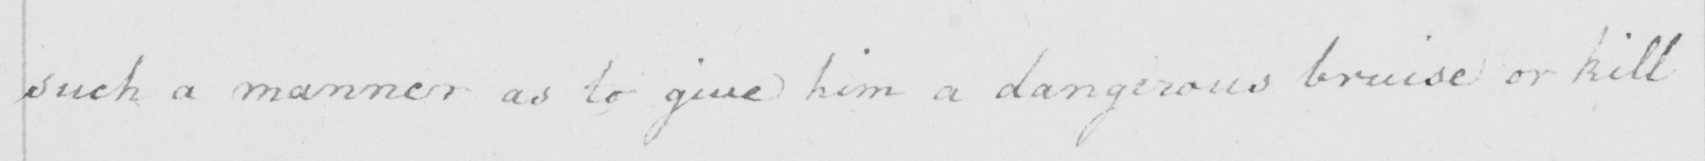Please provide the text content of this handwritten line. such a manner as to give him dangerous bruise or kill 